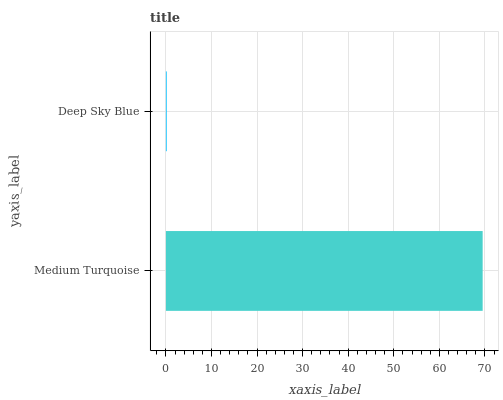Is Deep Sky Blue the minimum?
Answer yes or no. Yes. Is Medium Turquoise the maximum?
Answer yes or no. Yes. Is Deep Sky Blue the maximum?
Answer yes or no. No. Is Medium Turquoise greater than Deep Sky Blue?
Answer yes or no. Yes. Is Deep Sky Blue less than Medium Turquoise?
Answer yes or no. Yes. Is Deep Sky Blue greater than Medium Turquoise?
Answer yes or no. No. Is Medium Turquoise less than Deep Sky Blue?
Answer yes or no. No. Is Medium Turquoise the high median?
Answer yes or no. Yes. Is Deep Sky Blue the low median?
Answer yes or no. Yes. Is Deep Sky Blue the high median?
Answer yes or no. No. Is Medium Turquoise the low median?
Answer yes or no. No. 